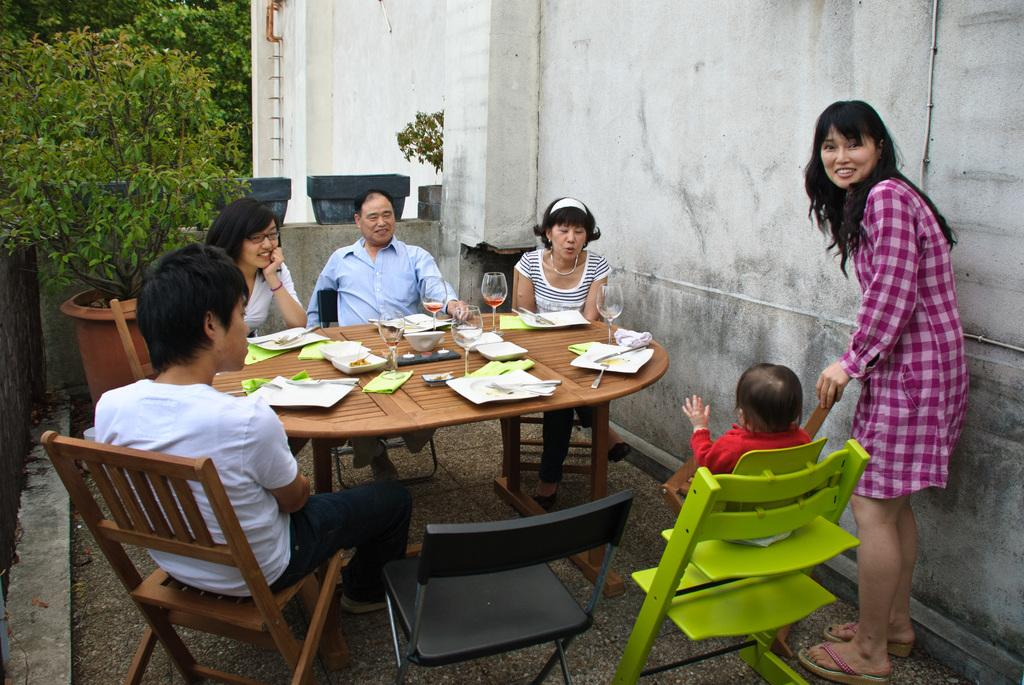What is happening in the image? There is a family in the image, and they are having food around a table. Can you describe the family's setting? The family is gathered around a table, which suggests they are sharing a meal together. What is the woman in the image doing? The woman is standing by the side of a baby, which might indicate that she is taking care of the child. What type of bears can be seen in the image? There are no bears present in the image; it features a family having food around a table. Does the image provide any information about the existence of extraterrestrial life? The image does not provide any information about the existence of extraterrestrial life; it focuses on a family having food around a table. 